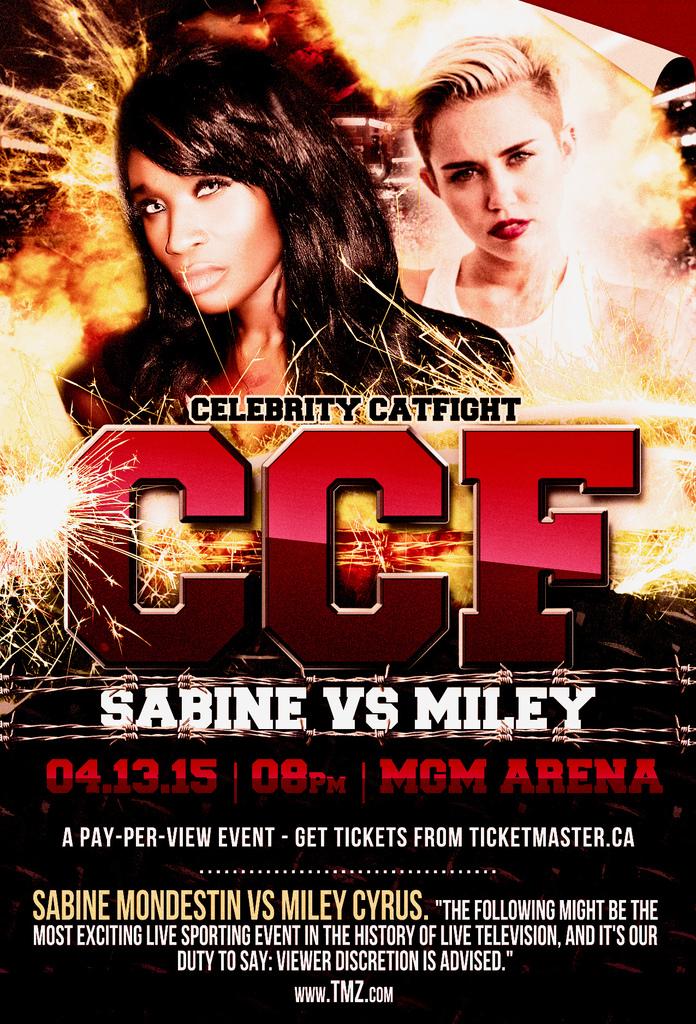Who is in the celebrity catfight?
Provide a succinct answer. Sabine vs miley. Where is the catfight being held?
Provide a succinct answer. Mgm arena. 